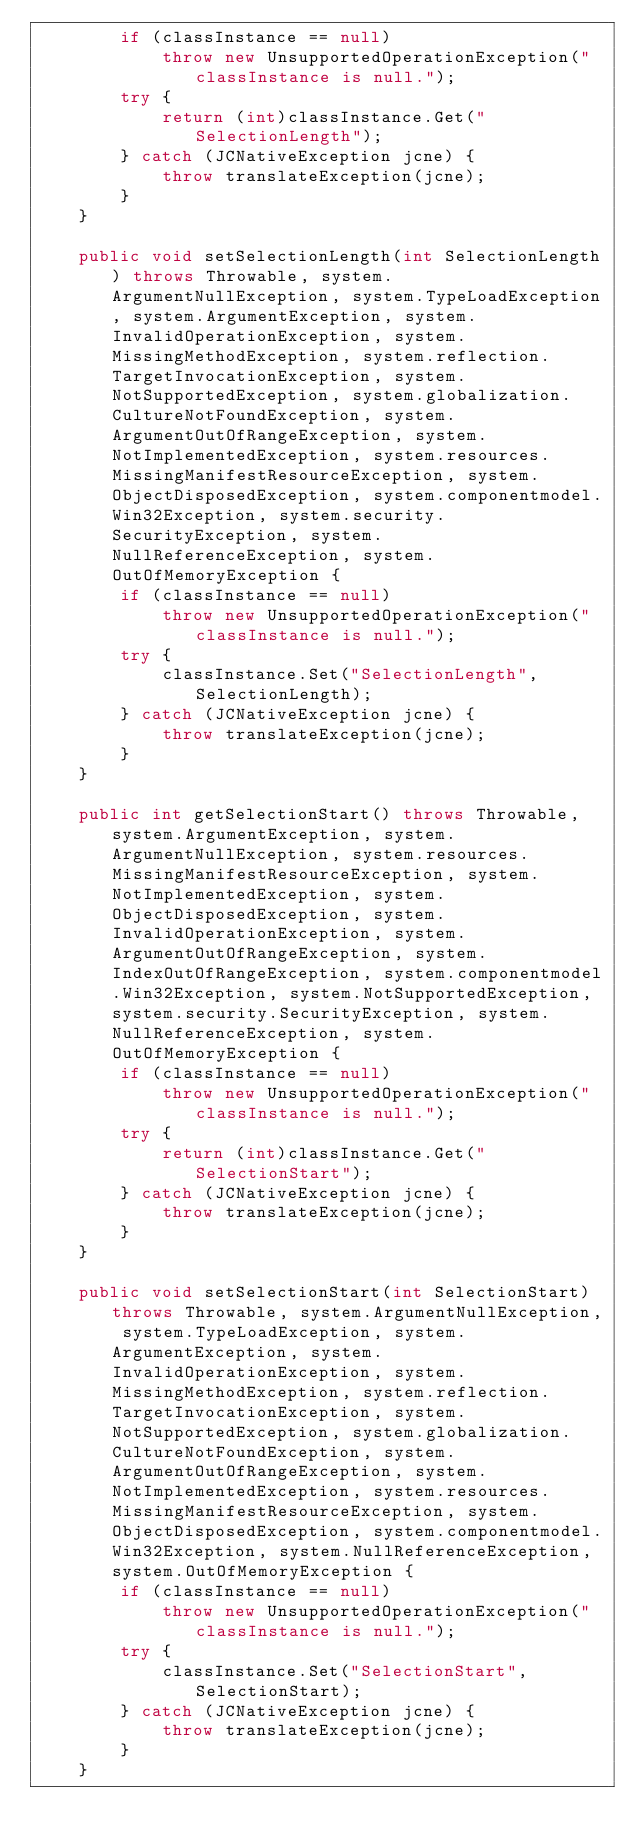Convert code to text. <code><loc_0><loc_0><loc_500><loc_500><_Java_>        if (classInstance == null)
            throw new UnsupportedOperationException("classInstance is null.");
        try {
            return (int)classInstance.Get("SelectionLength");
        } catch (JCNativeException jcne) {
            throw translateException(jcne);
        }
    }

    public void setSelectionLength(int SelectionLength) throws Throwable, system.ArgumentNullException, system.TypeLoadException, system.ArgumentException, system.InvalidOperationException, system.MissingMethodException, system.reflection.TargetInvocationException, system.NotSupportedException, system.globalization.CultureNotFoundException, system.ArgumentOutOfRangeException, system.NotImplementedException, system.resources.MissingManifestResourceException, system.ObjectDisposedException, system.componentmodel.Win32Exception, system.security.SecurityException, system.NullReferenceException, system.OutOfMemoryException {
        if (classInstance == null)
            throw new UnsupportedOperationException("classInstance is null.");
        try {
            classInstance.Set("SelectionLength", SelectionLength);
        } catch (JCNativeException jcne) {
            throw translateException(jcne);
        }
    }

    public int getSelectionStart() throws Throwable, system.ArgumentException, system.ArgumentNullException, system.resources.MissingManifestResourceException, system.NotImplementedException, system.ObjectDisposedException, system.InvalidOperationException, system.ArgumentOutOfRangeException, system.IndexOutOfRangeException, system.componentmodel.Win32Exception, system.NotSupportedException, system.security.SecurityException, system.NullReferenceException, system.OutOfMemoryException {
        if (classInstance == null)
            throw new UnsupportedOperationException("classInstance is null.");
        try {
            return (int)classInstance.Get("SelectionStart");
        } catch (JCNativeException jcne) {
            throw translateException(jcne);
        }
    }

    public void setSelectionStart(int SelectionStart) throws Throwable, system.ArgumentNullException, system.TypeLoadException, system.ArgumentException, system.InvalidOperationException, system.MissingMethodException, system.reflection.TargetInvocationException, system.NotSupportedException, system.globalization.CultureNotFoundException, system.ArgumentOutOfRangeException, system.NotImplementedException, system.resources.MissingManifestResourceException, system.ObjectDisposedException, system.componentmodel.Win32Exception, system.NullReferenceException, system.OutOfMemoryException {
        if (classInstance == null)
            throw new UnsupportedOperationException("classInstance is null.");
        try {
            classInstance.Set("SelectionStart", SelectionStart);
        } catch (JCNativeException jcne) {
            throw translateException(jcne);
        }
    }
</code> 